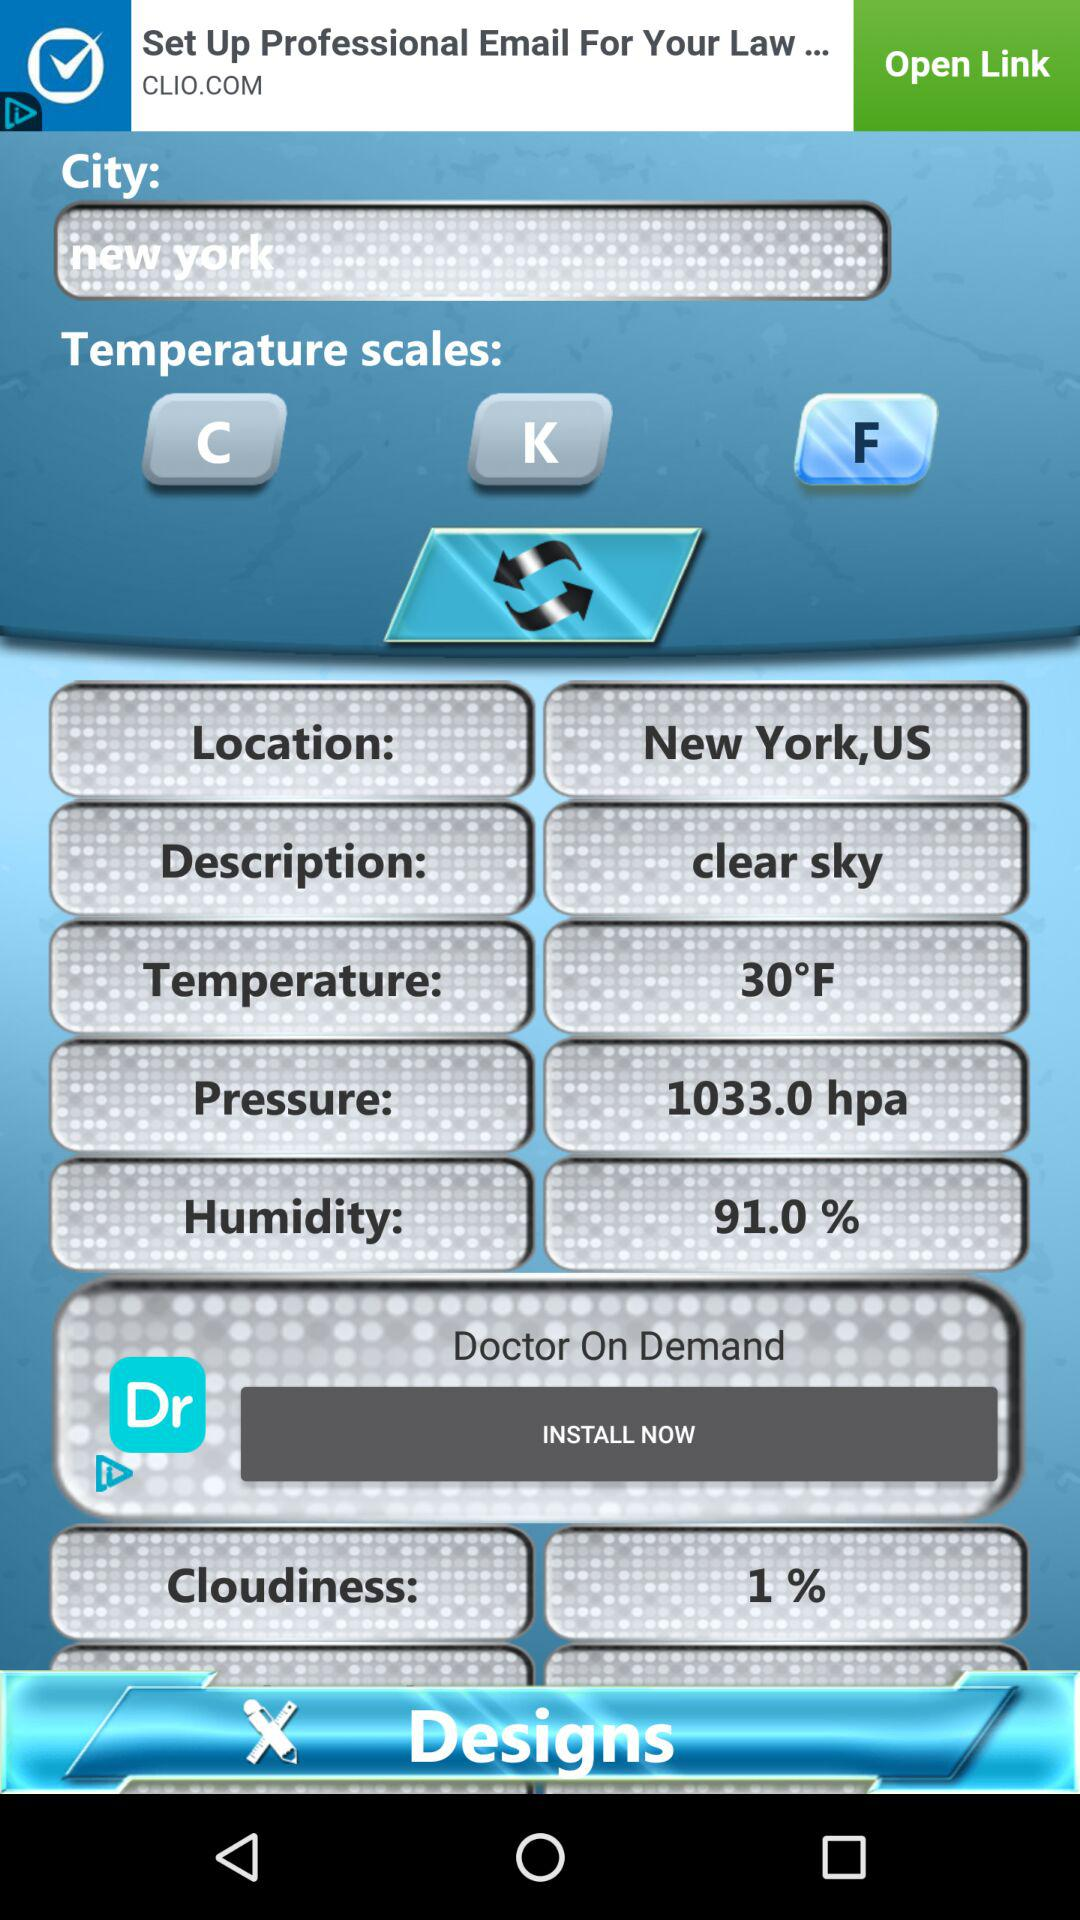What is the "Description" of New York? The "Description" is clear sky. 